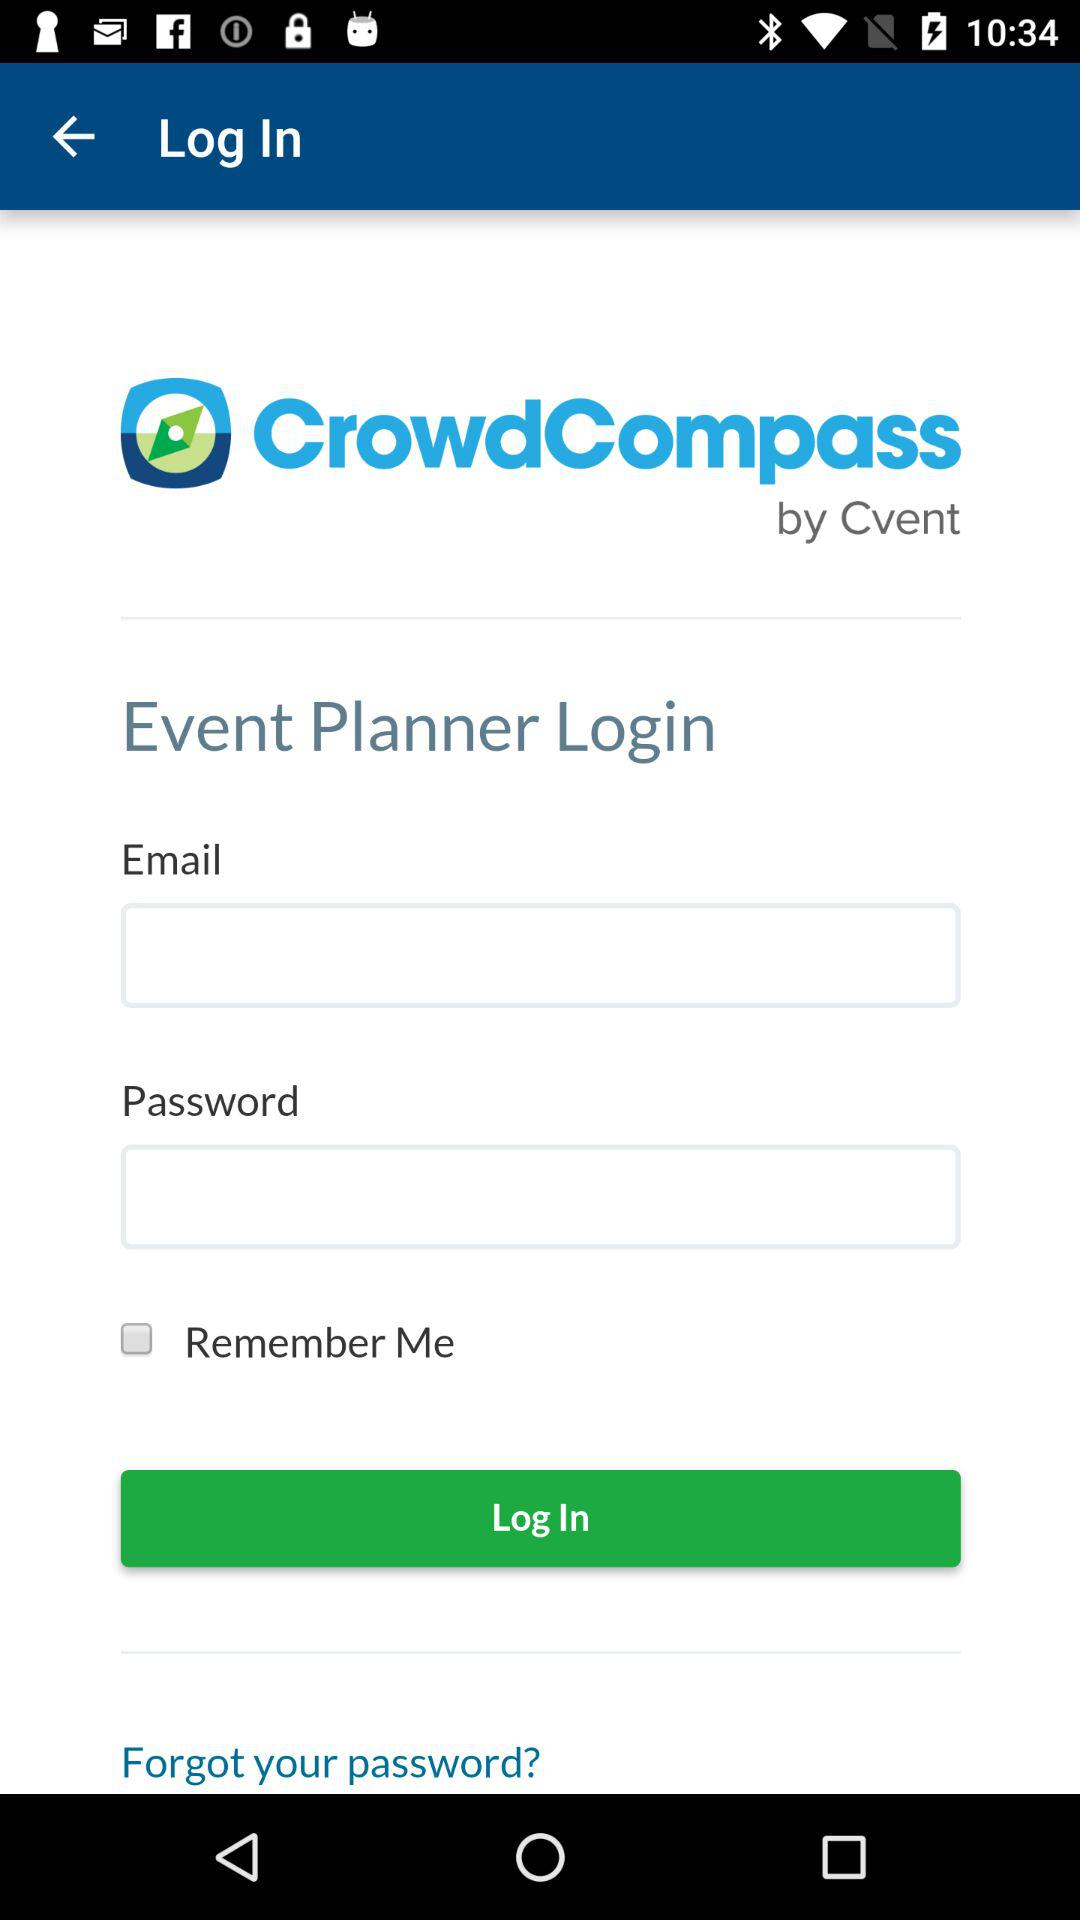What is the name of the application? The name of the application is "CrowdCompass". 